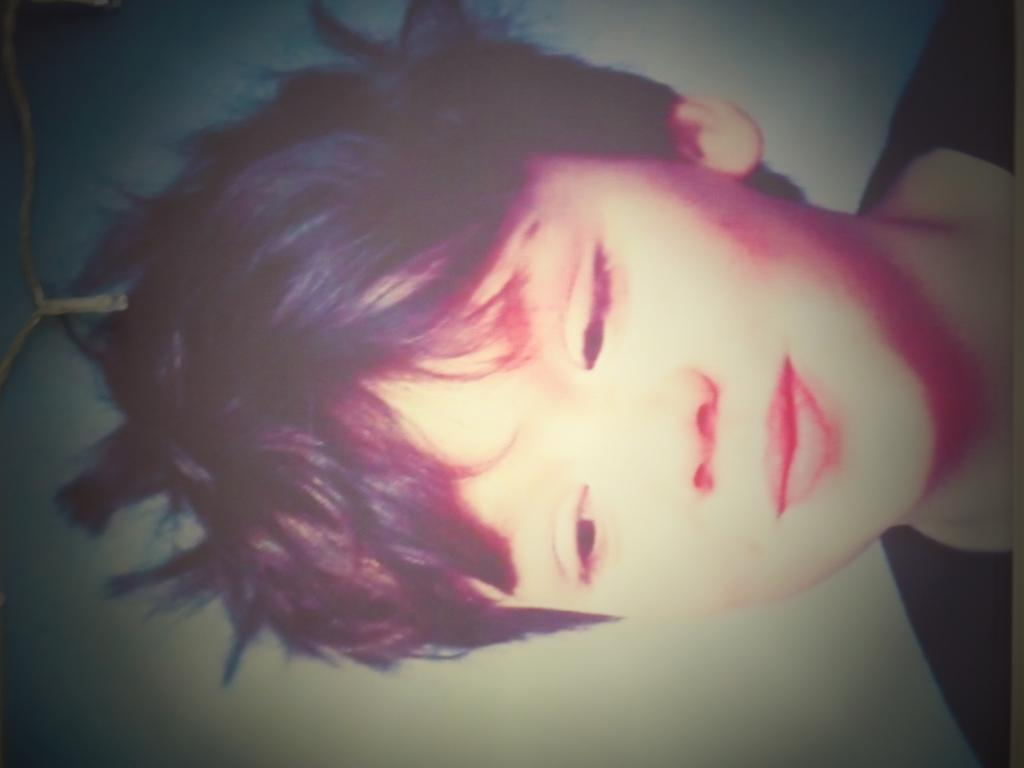What is the main subject of the image? There is a child in the image. What color are the clothes the child is wearing? The child is wearing black clothes. What is the color of the background in the image? The background of the image is white. Can you tell me how many wings the child has in the image? There are no wings visible on the child in the image. What type of legal advice is the child seeking in the image? There is no indication in the image that the child is seeking legal advice or interacting with a lawyer. 